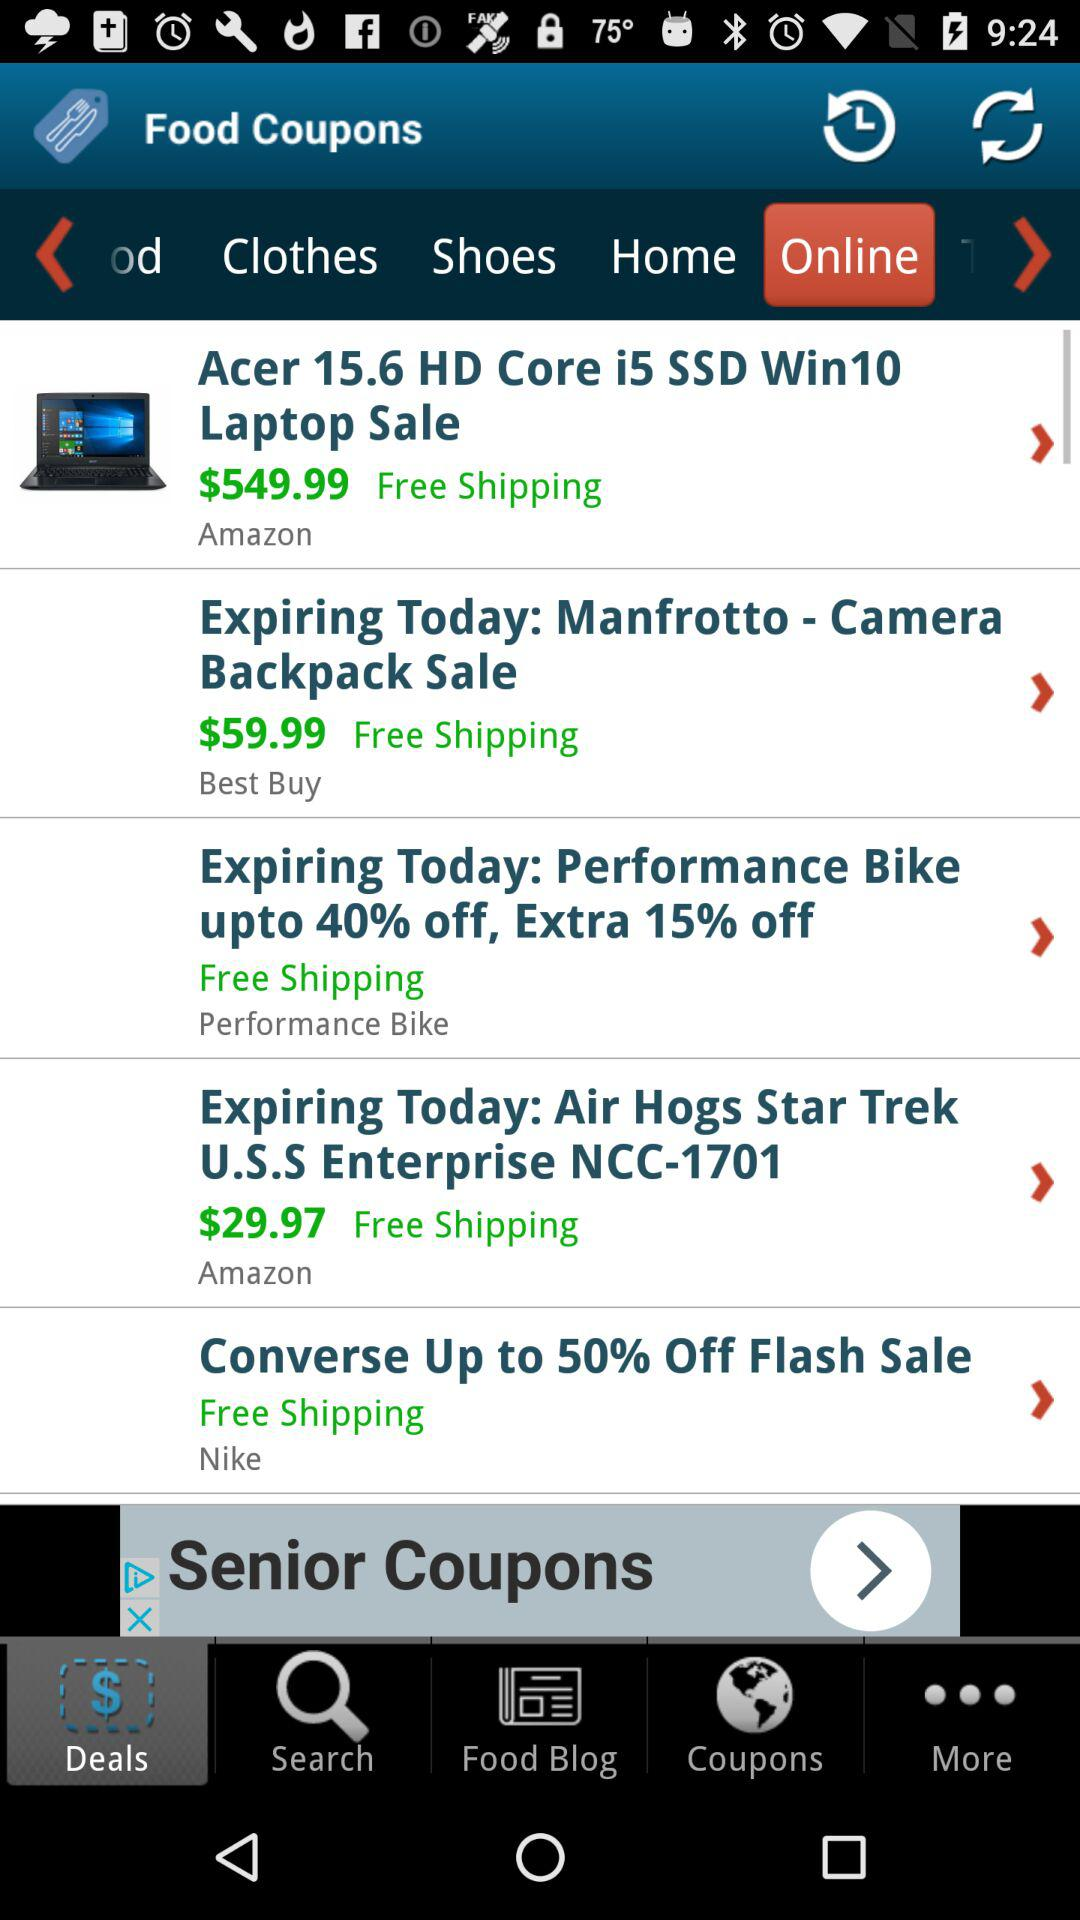What is the price of the laptop? The price of the laptop is $549.99. 